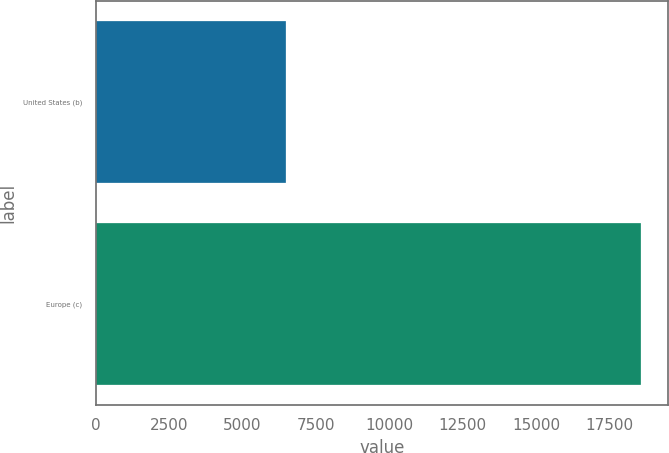Convert chart. <chart><loc_0><loc_0><loc_500><loc_500><bar_chart><fcel>United States (b)<fcel>Europe (c)<nl><fcel>6468<fcel>18571<nl></chart> 